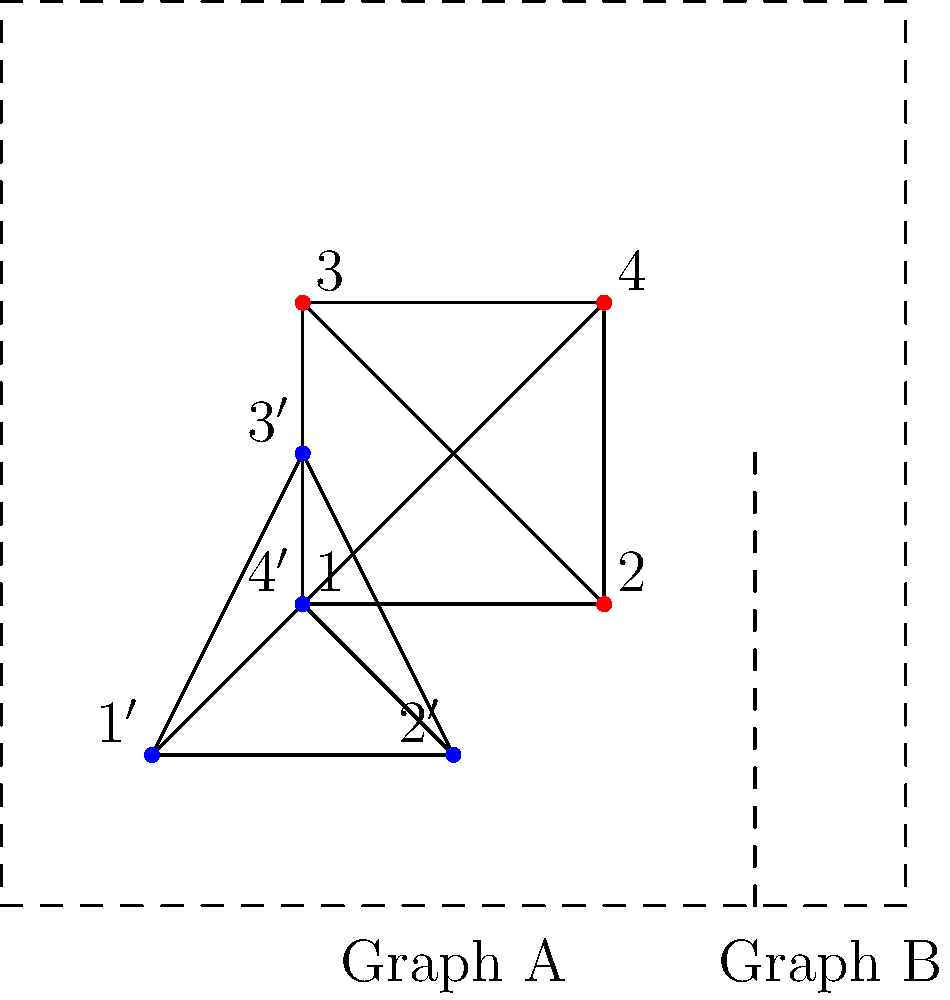Consider the two chemical structures represented by Graph A and Graph B. Are these structures isomorphic? If so, provide the vertex mapping between Graph A and Graph B. To determine if the two graphs are isomorphic, we need to follow these steps:

1. Check if both graphs have the same number of vertices and edges:
   Both graphs have 4 vertices and 6 edges.

2. Check if the degree sequence of both graphs is the same:
   In both graphs, each vertex has a degree of 3.

3. Look for a bijective mapping between vertices that preserves edge connections:
   We can map the vertices as follows:
   1 → 2'
   2 → 1'
   3 → 4'
   4 → 3'

4. Verify that this mapping preserves edge connections:
   - Edge (1,2) in Graph A corresponds to (2',1') in Graph B
   - Edge (1,3) in Graph A corresponds to (2',4') in Graph B
   - Edge (1,4) in Graph A corresponds to (2',3') in Graph B
   - Edge (2,3) in Graph A corresponds to (1',4') in Graph B
   - Edge (2,4) in Graph A corresponds to (1',3') in Graph B
   - Edge (3,4) in Graph A corresponds to (4',3') in Graph B

5. Conclusion:
   Since we found a bijective mapping that preserves edge connections, the graphs are isomorphic.
Answer: Yes, isomorphic. Mapping: 1→2', 2→1', 3→4', 4→3' 